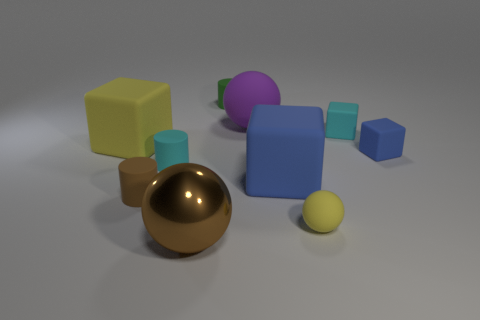Is there anything else that is the same material as the large brown sphere?
Make the answer very short. No. There is a large ball that is in front of the tiny blue object right of the matte ball in front of the large yellow rubber block; what is its material?
Your answer should be very brief. Metal. Is the number of large purple objects in front of the shiny thing the same as the number of cubes?
Offer a very short reply. No. How many things are either cylinders or brown rubber cylinders?
Make the answer very short. 3. What is the shape of the small cyan object that is made of the same material as the tiny cyan cylinder?
Your answer should be very brief. Cube. What is the size of the green cylinder that is behind the cyan object right of the big brown ball?
Give a very brief answer. Small. How many tiny things are either purple matte things or brown objects?
Offer a very short reply. 1. How many other objects are there of the same color as the large rubber ball?
Provide a succinct answer. 0. Does the yellow object that is behind the small brown cylinder have the same size as the blue cube that is in front of the tiny cyan matte cylinder?
Give a very brief answer. Yes. Are the brown ball and the tiny cylinder that is in front of the tiny cyan cylinder made of the same material?
Make the answer very short. No. 